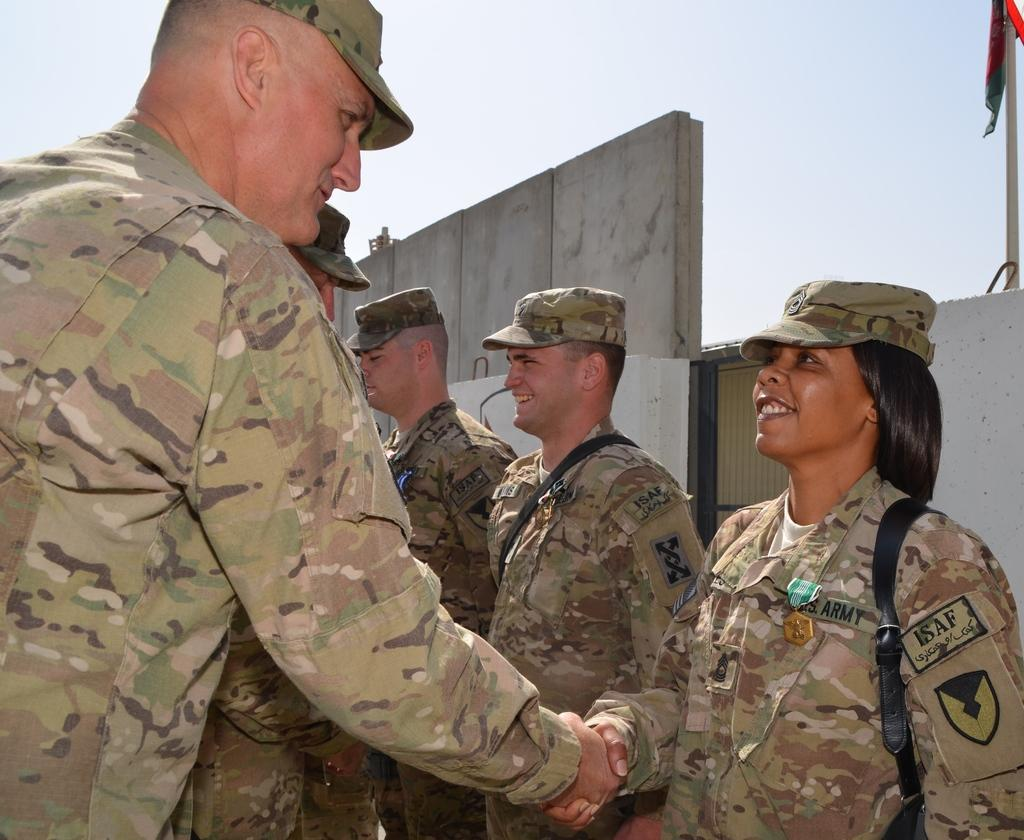Who are the people in the image? The people in the image are wearing uniforms and caps. What can be observed on some of the faces in the image? There are smiles present? What is in the background of the image? There is a pole with a flag on it in the background, and the sky is also visible. What type of addition problem can be solved by the people in the image? There is no addition problem present in the image; it features people wearing uniforms and caps with smiles on their faces. What offer is being made by the people in the image? There is no offer being made by the people in the image; they are simply wearing uniforms, caps, and smiling. 